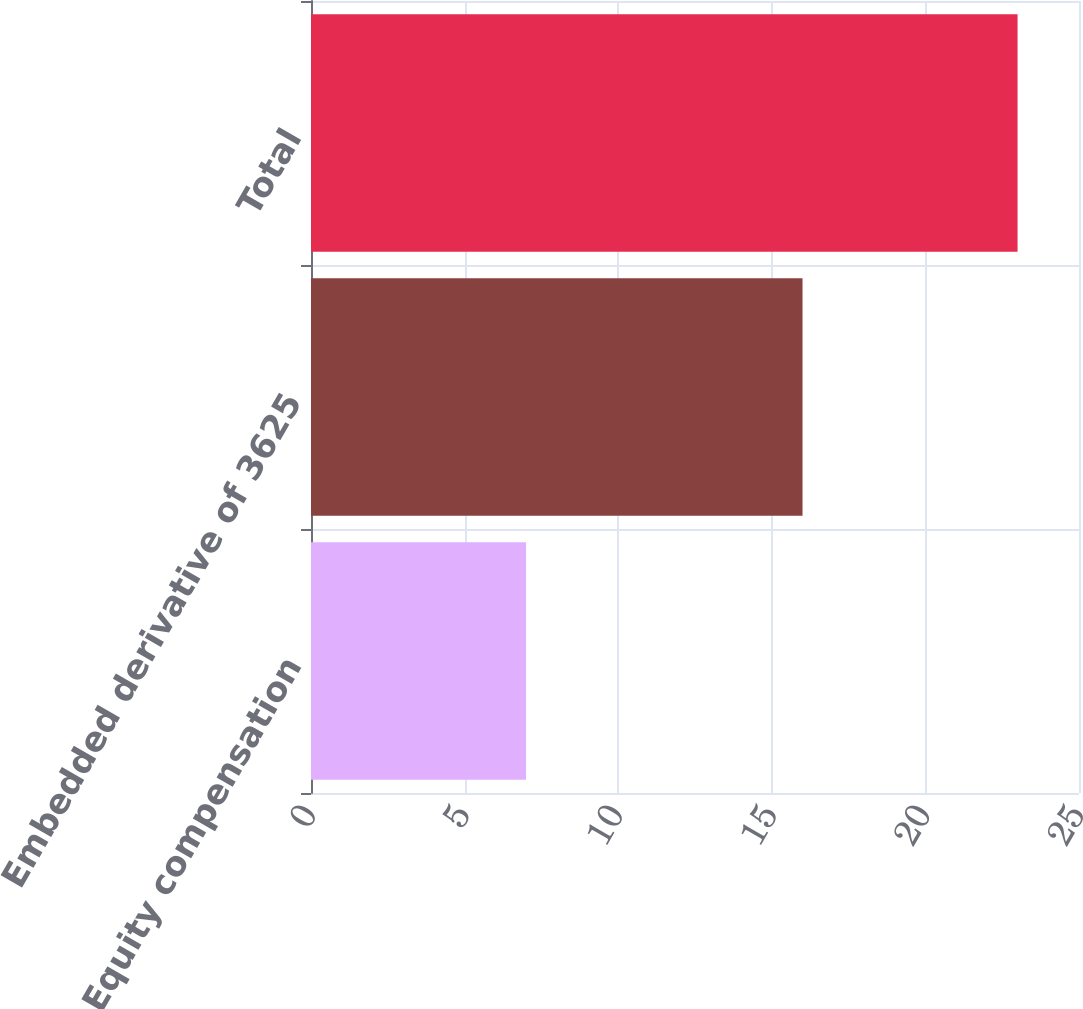Convert chart to OTSL. <chart><loc_0><loc_0><loc_500><loc_500><bar_chart><fcel>Equity compensation<fcel>Embedded derivative of 3625<fcel>Total<nl><fcel>7<fcel>16<fcel>23<nl></chart> 